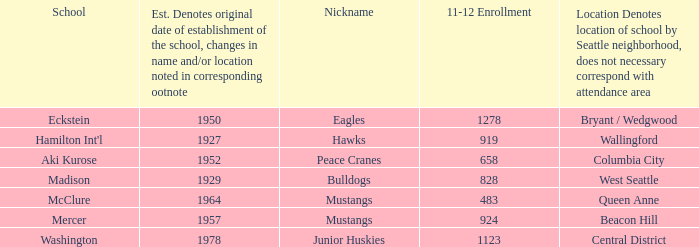Name the minimum 11-12 enrollment for washington school 1123.0. 